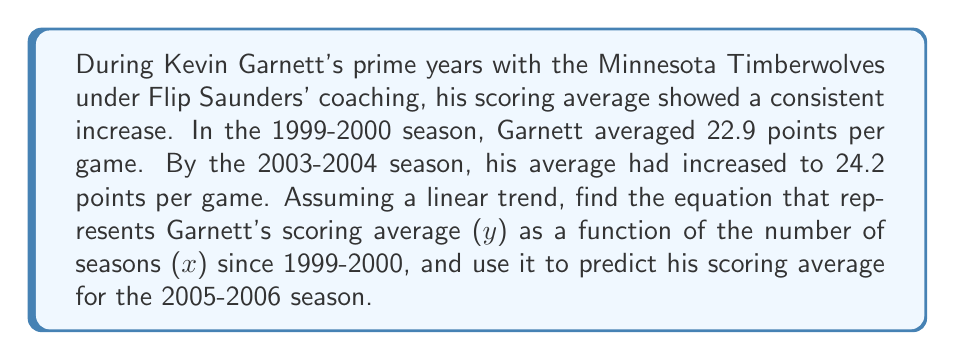Provide a solution to this math problem. Let's approach this step-by-step:

1) We need to find the linear equation in the form $y = mx + b$, where:
   $y$ = scoring average
   $x$ = number of seasons since 1999-2000
   $m$ = slope (rate of change in scoring average per season)
   $b$ = y-intercept (scoring average in the 1999-2000 season)

2) We have two points:
   (0, 22.9) for 1999-2000 season
   (4, 24.2) for 2003-2004 season (4 seasons later)

3) Calculate the slope:
   $m = \frac{y_2 - y_1}{x_2 - x_1} = \frac{24.2 - 22.9}{4 - 0} = \frac{1.3}{4} = 0.325$

4) The y-intercept $b$ is the scoring average in 1999-2000, which is 22.9.

5) Therefore, the linear equation is:
   $y = 0.325x + 22.9$

6) To predict the scoring average for 2005-2006, we need to plug in $x = 6$ (6 seasons after 1999-2000):
   $y = 0.325(6) + 22.9 = 1.95 + 22.9 = 24.85$

So, the predicted scoring average for the 2005-2006 season is 24.85 points per game.
Answer: $y = 0.325x + 22.9$; 24.85 points per game for 2005-2006 